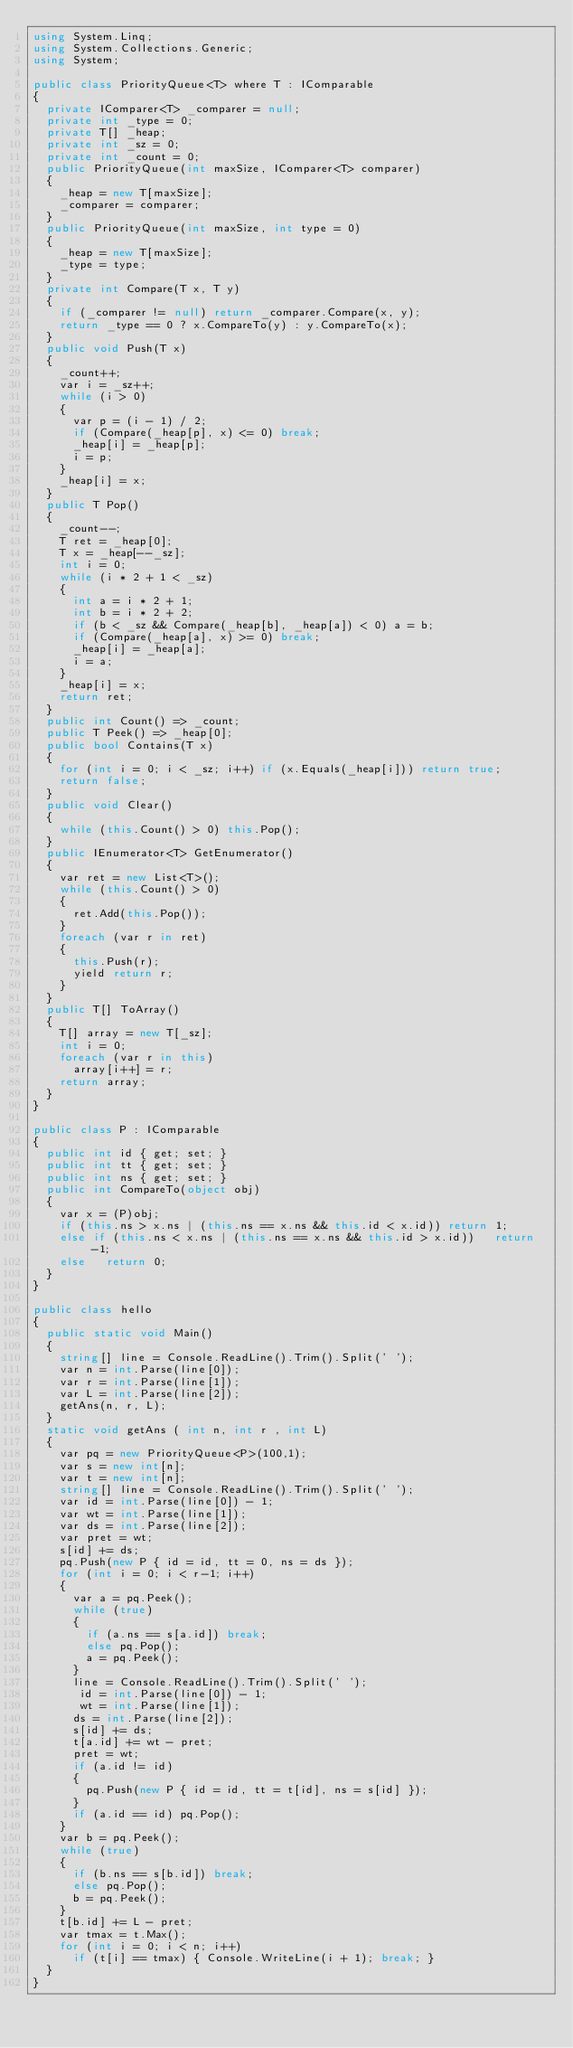Convert code to text. <code><loc_0><loc_0><loc_500><loc_500><_C#_>using System.Linq;
using System.Collections.Generic;
using System;

public class PriorityQueue<T> where T : IComparable
{
	private IComparer<T> _comparer = null;
	private int _type = 0;
	private T[] _heap;
	private int _sz = 0;
	private int _count = 0;
	public PriorityQueue(int maxSize, IComparer<T> comparer)
	{
		_heap = new T[maxSize];
		_comparer = comparer;
	}
	public PriorityQueue(int maxSize, int type = 0)
	{
		_heap = new T[maxSize];
		_type = type;
	}
	private int Compare(T x, T y)
	{
		if (_comparer != null) return _comparer.Compare(x, y);
		return _type == 0 ? x.CompareTo(y) : y.CompareTo(x);
	}
	public void Push(T x)
	{
		_count++;
		var i = _sz++;
		while (i > 0)
		{
			var p = (i - 1) / 2;
			if (Compare(_heap[p], x) <= 0) break;
			_heap[i] = _heap[p];
			i = p;
		}
		_heap[i] = x;
	}
	public T Pop()
	{
		_count--;
		T ret = _heap[0];
		T x = _heap[--_sz];
		int i = 0;
		while (i * 2 + 1 < _sz)
		{
			int a = i * 2 + 1;
			int b = i * 2 + 2;
			if (b < _sz && Compare(_heap[b], _heap[a]) < 0) a = b;
			if (Compare(_heap[a], x) >= 0) break;
			_heap[i] = _heap[a];
			i = a;
		}
		_heap[i] = x;
		return ret;
	}
	public int Count() => _count;
	public T Peek() => _heap[0];
	public bool Contains(T x)
	{
		for (int i = 0; i < _sz; i++) if (x.Equals(_heap[i])) return true;
		return false;
	}
	public void Clear()
	{
		while (this.Count() > 0) this.Pop();
	}
	public IEnumerator<T> GetEnumerator()
	{
		var ret = new List<T>();
		while (this.Count() > 0)
		{
			ret.Add(this.Pop());
		}
		foreach (var r in ret)
		{
			this.Push(r);
			yield return r;
		}
	}
	public T[] ToArray()
	{
		T[] array = new T[_sz];
		int i = 0;
		foreach (var r in this)
			array[i++] = r;
		return array;
	}
}

public class P : IComparable
{
	public int id { get; set; }
	public int tt { get; set; }
	public int ns { get; set; }
	public int CompareTo(object obj)
	{
		var x = (P)obj;
		if (this.ns > x.ns | (this.ns == x.ns && this.id < x.id)) return 1;
		else if (this.ns < x.ns | (this.ns == x.ns && this.id > x.id))   return -1;
		else   return 0;
	}
}

public class hello
{
	public static void Main()
	{
		string[] line = Console.ReadLine().Trim().Split(' ');
		var n = int.Parse(line[0]);
		var r = int.Parse(line[1]);
		var L = int.Parse(line[2]);
		getAns(n, r, L);
	}
	static void getAns ( int n, int r , int L)
	{
		var pq = new PriorityQueue<P>(100,1);
		var s = new int[n];
		var t = new int[n];
		string[] line = Console.ReadLine().Trim().Split(' ');
		var id = int.Parse(line[0]) - 1;
		var wt = int.Parse(line[1]);
		var ds = int.Parse(line[2]);
		var pret = wt;
		s[id] += ds;
		pq.Push(new P { id = id, tt = 0, ns = ds });
		for (int i = 0; i < r-1; i++)
		{
			var a = pq.Peek();
			while (true)
			{
				if (a.ns == s[a.id]) break;
				else pq.Pop();
				a = pq.Peek();
			}
			line = Console.ReadLine().Trim().Split(' ');
			 id = int.Parse(line[0]) - 1;
			 wt = int.Parse(line[1]);
			ds = int.Parse(line[2]);
			s[id] += ds;
			t[a.id] += wt - pret;
			pret = wt;
			if (a.id != id)
			{
				pq.Push(new P { id = id, tt = t[id], ns = s[id] });
			}
			if (a.id == id) pq.Pop();
		}
		var b = pq.Peek();
		while (true)
		{
			if (b.ns == s[b.id]) break;
			else pq.Pop();
			b = pq.Peek();
		}
		t[b.id] += L - pret;
		var tmax = t.Max();
		for (int i = 0; i < n; i++)
			if (t[i] == tmax) { Console.WriteLine(i + 1); break; }
	}
}

</code> 